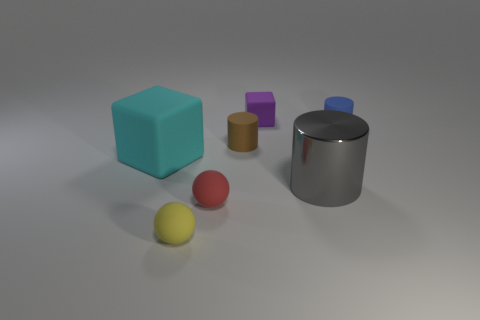Add 3 brown metallic balls. How many objects exist? 10 Subtract all tiny matte cylinders. How many cylinders are left? 1 Subtract all balls. How many objects are left? 5 Subtract 3 cylinders. How many cylinders are left? 0 Add 4 tiny yellow rubber blocks. How many tiny yellow rubber blocks exist? 4 Subtract all brown cylinders. How many cylinders are left? 2 Subtract 0 yellow cylinders. How many objects are left? 7 Subtract all red balls. Subtract all green cylinders. How many balls are left? 1 Subtract all big yellow matte cylinders. Subtract all small red rubber spheres. How many objects are left? 6 Add 5 tiny purple things. How many tiny purple things are left? 6 